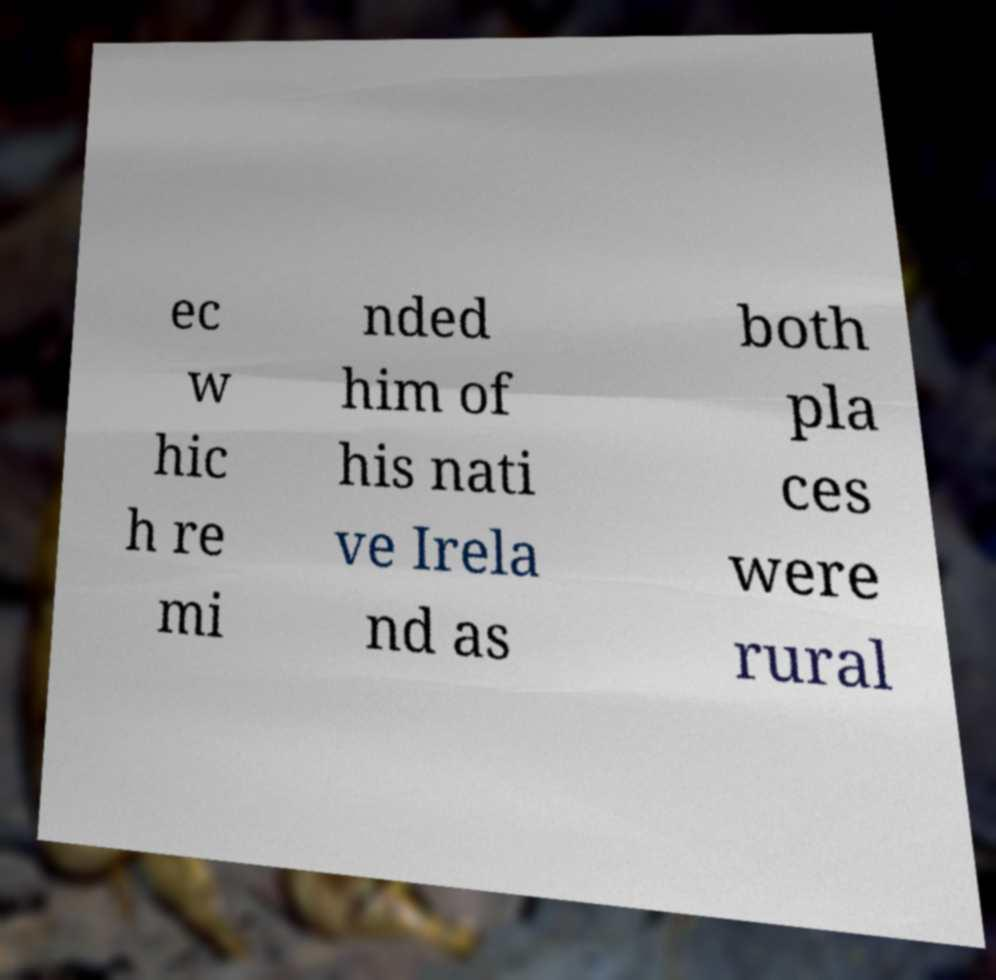Could you extract and type out the text from this image? ec w hic h re mi nded him of his nati ve Irela nd as both pla ces were rural 